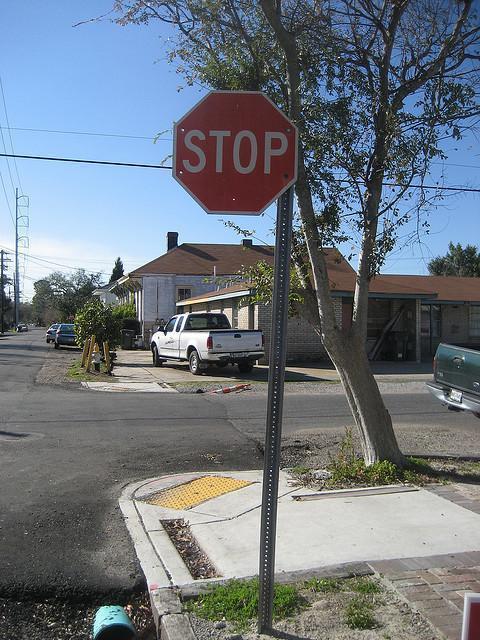How many street signs are in the photo?
Give a very brief answer. 1. How many flags are on the building?
Give a very brief answer. 0. How many trucks can be seen?
Give a very brief answer. 2. How many vases are blue?
Give a very brief answer. 0. 